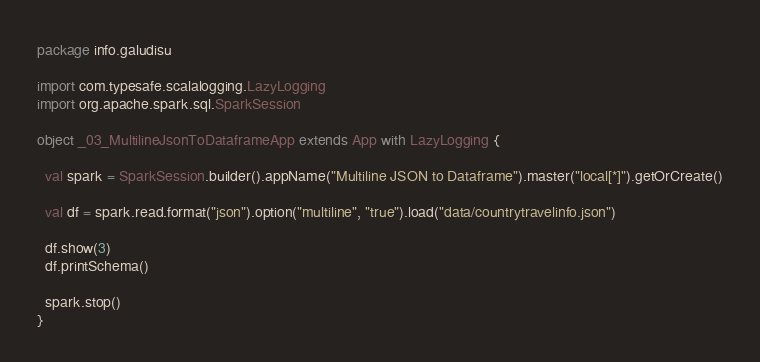Convert code to text. <code><loc_0><loc_0><loc_500><loc_500><_Scala_>package info.galudisu

import com.typesafe.scalalogging.LazyLogging
import org.apache.spark.sql.SparkSession

object _03_MultilineJsonToDataframeApp extends App with LazyLogging {

  val spark = SparkSession.builder().appName("Multiline JSON to Dataframe").master("local[*]").getOrCreate()

  val df = spark.read.format("json").option("multiline", "true").load("data/countrytravelinfo.json")

  df.show(3)
  df.printSchema()

  spark.stop()
}
</code> 